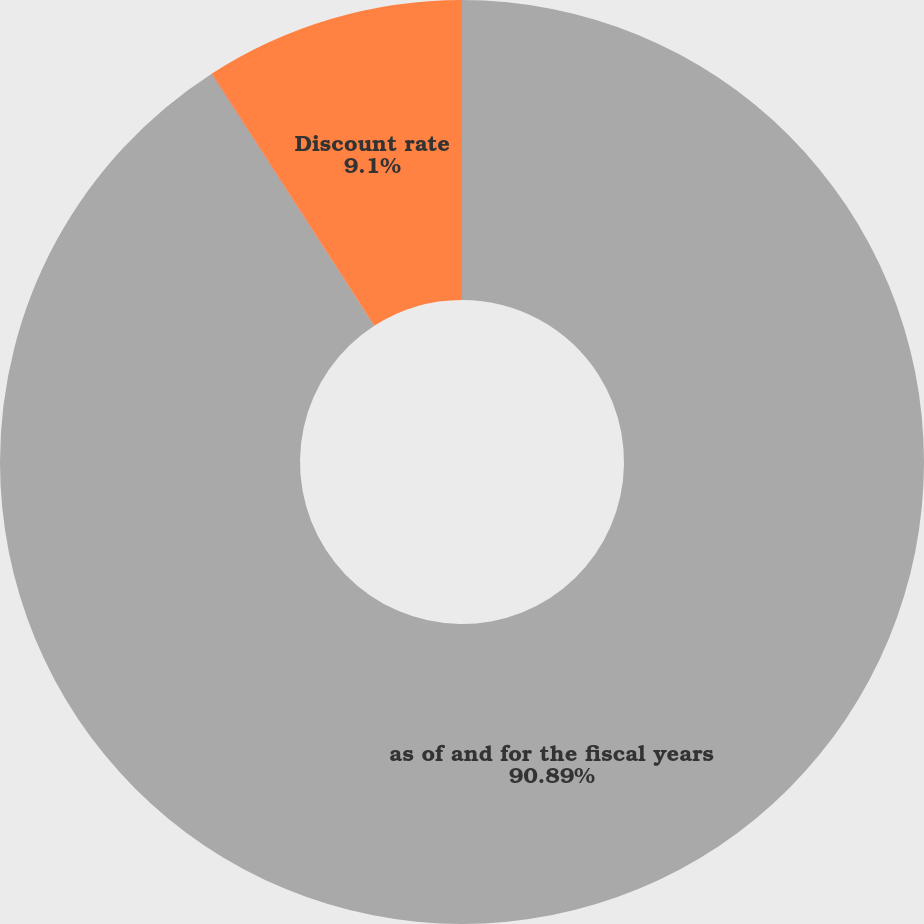Convert chart. <chart><loc_0><loc_0><loc_500><loc_500><pie_chart><fcel>as of and for the fiscal years<fcel>Net Asset (Liability)<fcel>Discount rate<nl><fcel>90.89%<fcel>0.01%<fcel>9.1%<nl></chart> 